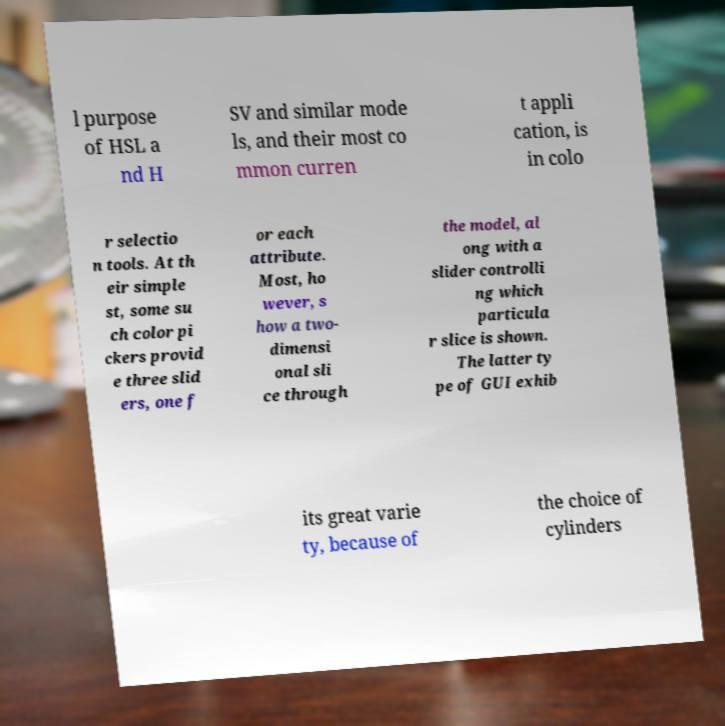Please read and relay the text visible in this image. What does it say? l purpose of HSL a nd H SV and similar mode ls, and their most co mmon curren t appli cation, is in colo r selectio n tools. At th eir simple st, some su ch color pi ckers provid e three slid ers, one f or each attribute. Most, ho wever, s how a two- dimensi onal sli ce through the model, al ong with a slider controlli ng which particula r slice is shown. The latter ty pe of GUI exhib its great varie ty, because of the choice of cylinders 